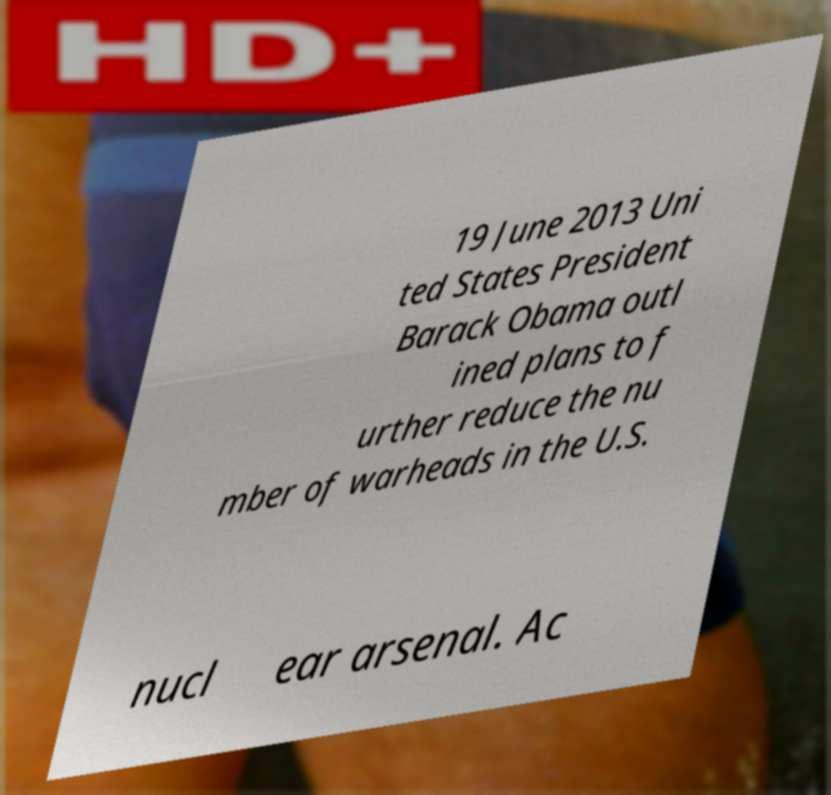For documentation purposes, I need the text within this image transcribed. Could you provide that? 19 June 2013 Uni ted States President Barack Obama outl ined plans to f urther reduce the nu mber of warheads in the U.S. nucl ear arsenal. Ac 